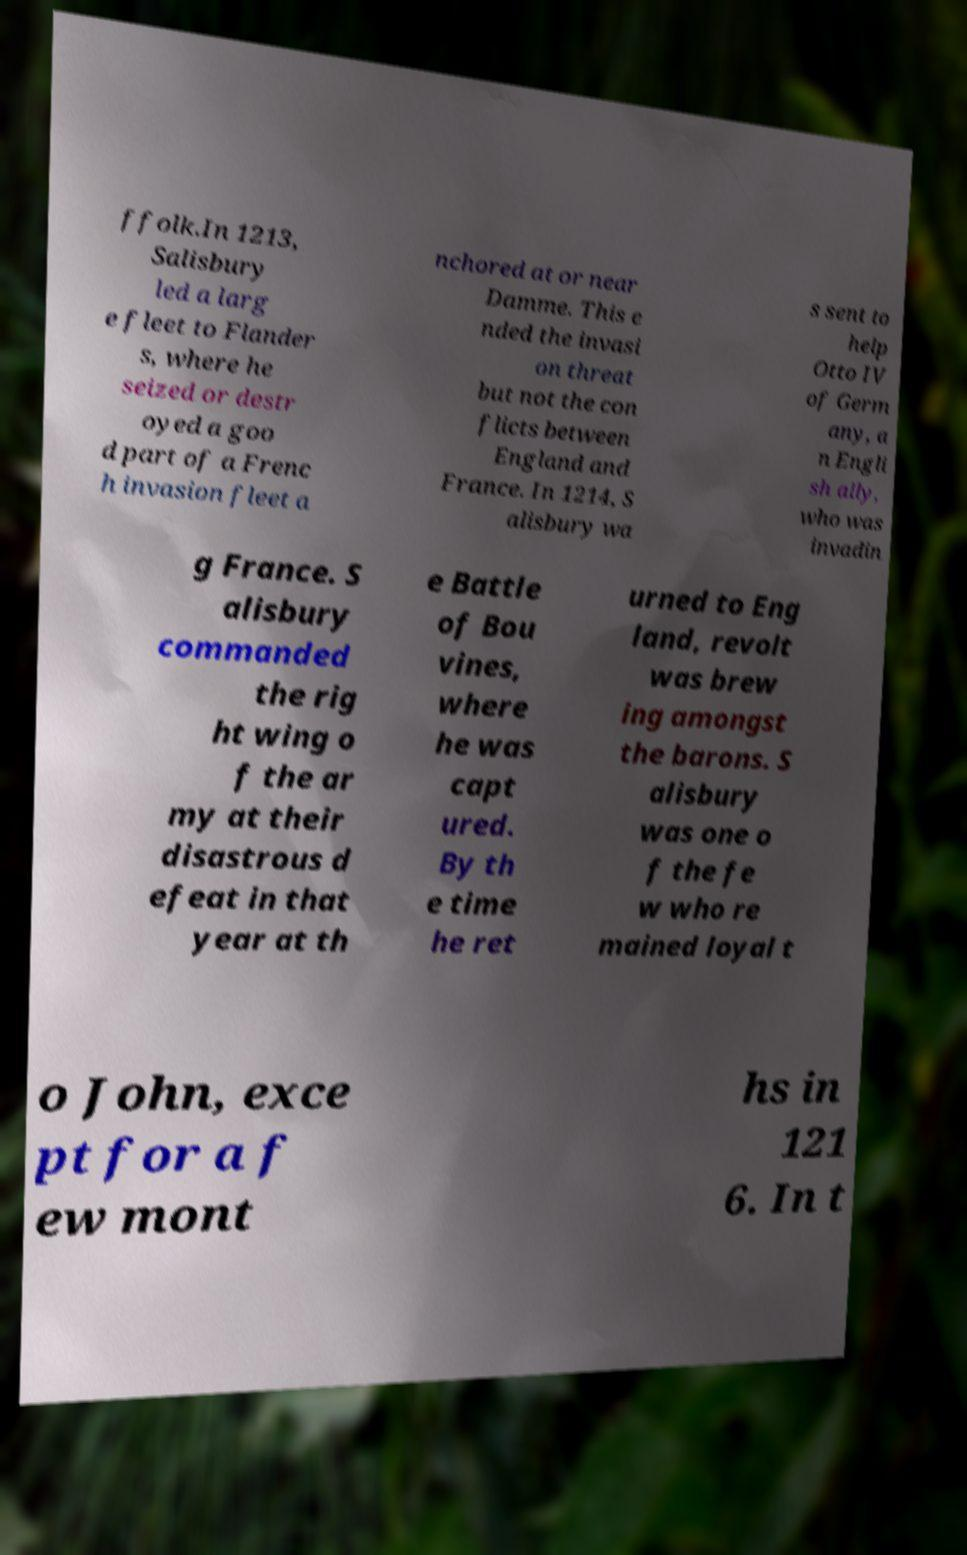Can you read and provide the text displayed in the image?This photo seems to have some interesting text. Can you extract and type it out for me? ffolk.In 1213, Salisbury led a larg e fleet to Flander s, where he seized or destr oyed a goo d part of a Frenc h invasion fleet a nchored at or near Damme. This e nded the invasi on threat but not the con flicts between England and France. In 1214, S alisbury wa s sent to help Otto IV of Germ any, a n Engli sh ally, who was invadin g France. S alisbury commanded the rig ht wing o f the ar my at their disastrous d efeat in that year at th e Battle of Bou vines, where he was capt ured. By th e time he ret urned to Eng land, revolt was brew ing amongst the barons. S alisbury was one o f the fe w who re mained loyal t o John, exce pt for a f ew mont hs in 121 6. In t 